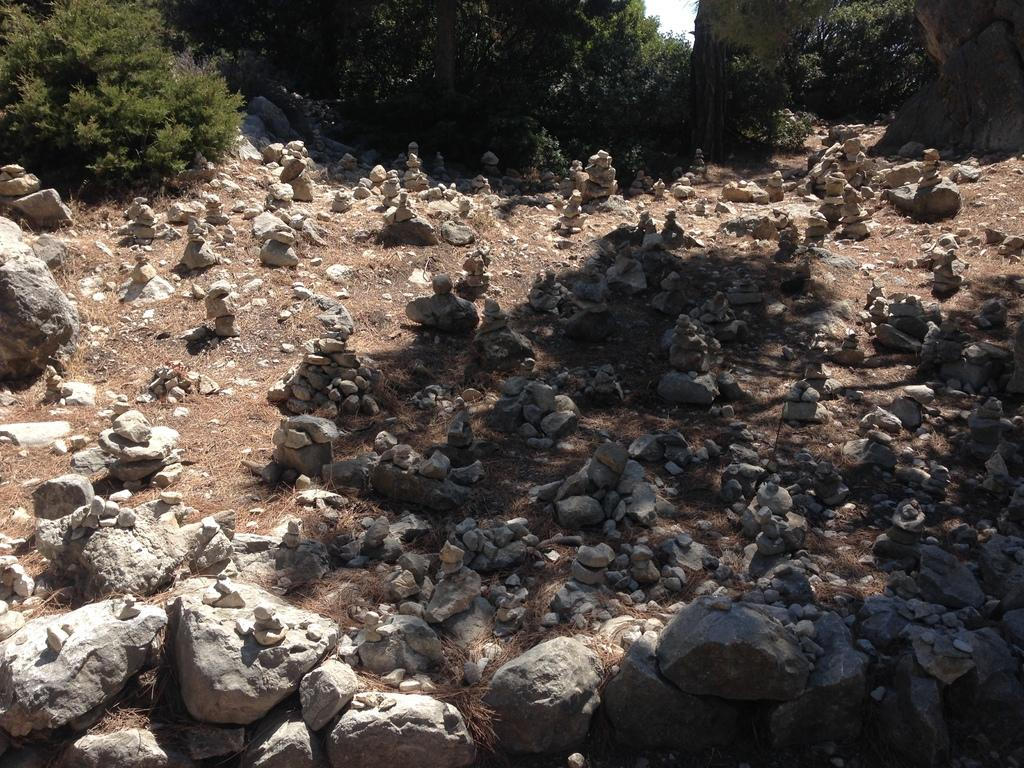What type of natural elements can be seen on the ground in the image? There are rocks on the ground in the image. What type of vegetation can be seen in the background of the image? There are trees in the background of the image. How many horses are present in the bedroom in the image? There are no horses or bedrooms present in the image; it features rocks on the ground and trees in the background. 